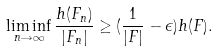<formula> <loc_0><loc_0><loc_500><loc_500>\liminf _ { n \rightarrow \infty } \frac { h ( F _ { n } ) } { | F _ { n } | } \geq ( \frac { 1 } { | F | } - \epsilon ) h ( F ) .</formula> 